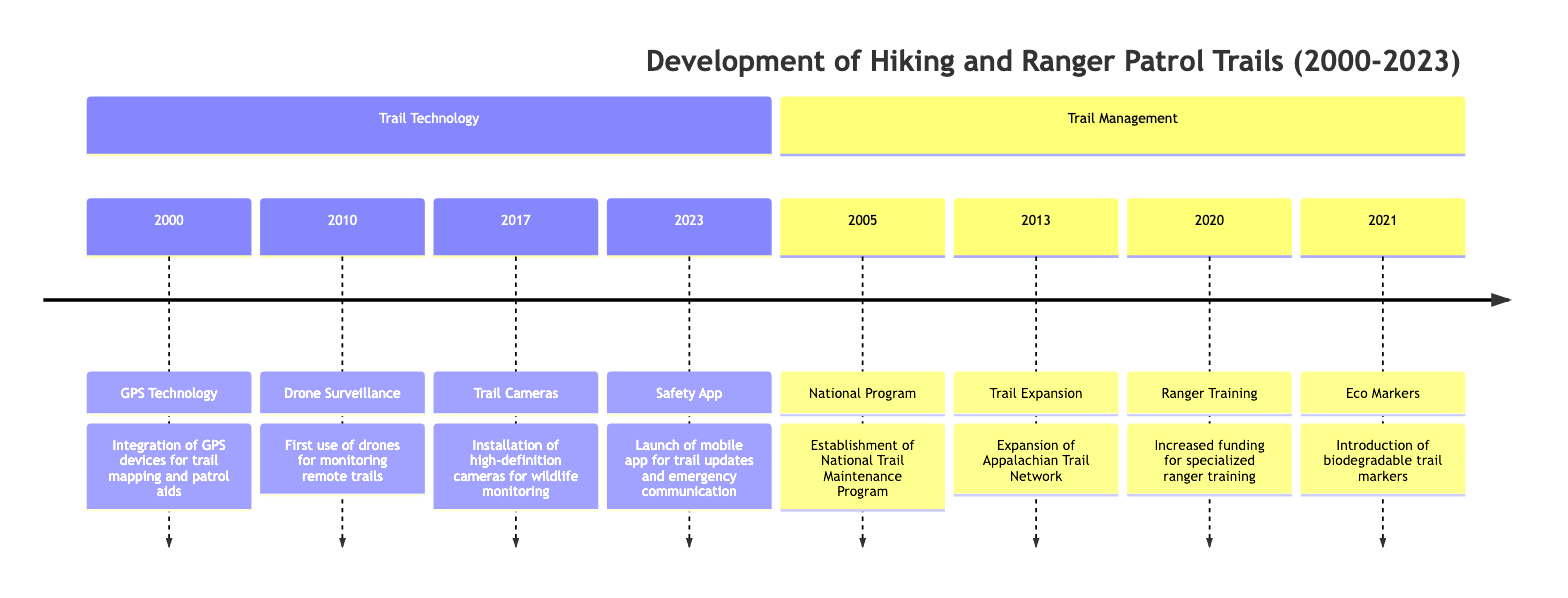What event marks the introduction of GPS technology? The diagram shows that the event of "GPS Technology" was introduced in the year 2000, indicating the start of integrating GPS devices for trail mapping.
Answer: GPS Technology How many major events are listed for the year 2010? According to the timeline, there is only one event listed for the year 2010, which is the "First Use of Drones for Trail Surveillance." Therefore, the total count of events is one.
Answer: 1 What year did the establishment of the National Trail Maintenance Program occur? By examining the timeline, the event "National Program" clearly states it was established in the year 2005, which indicates when this initiative started.
Answer: 2005 Which technological advancement was implemented first for trail surveillance? The diagram highlights that the "First Use of Drones for Trail Surveillance" occurred in the year 2010, making it the first implementation compared to the other advancements listed.
Answer: Drones How many years were there between the introduction of eco-friendly trail markers and the launch of the safety mobile app? The eco-friendly trail markers were introduced in 2021 and the mobile app was launched in 2023, which results in a difference of two years between the two events.
Answer: 2 What is the last event depicted in the timeline? The last event, according to the timeline structure, occurs in 2023 and is the "Launch of Trail Safety Mobile App," which is the most recent development mentioned.
Answer: Launch of Trail Safety Mobile App What type of technology was first used in 2017 for monitoring wildlife? In the year 2017, the event listed is "Installation of high-definition cameras," indicating this specific technology was first utilized for monitoring wildlife on trails in that year.
Answer: High-definition cameras Name one year when a trail management initiative was established. The timeline indicates that 2005 is the year when the "National Trail Maintenance Program" was established, making it one specific year that highlights trail management.
Answer: 2005 Which section contains information about trail technology? Upon reviewing the timeline, it’s clear that the "Trail Technology" section includes events related to advancements in technology used for trails over the years, showing its focus on that aspect.
Answer: Trail Technology 